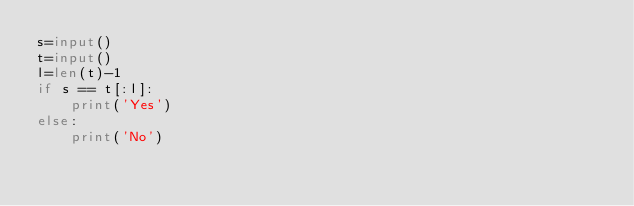Convert code to text. <code><loc_0><loc_0><loc_500><loc_500><_Python_>s=input()
t=input()
l=len(t)-1
if s == t[:l]:
    print('Yes')
else:
    print('No')</code> 